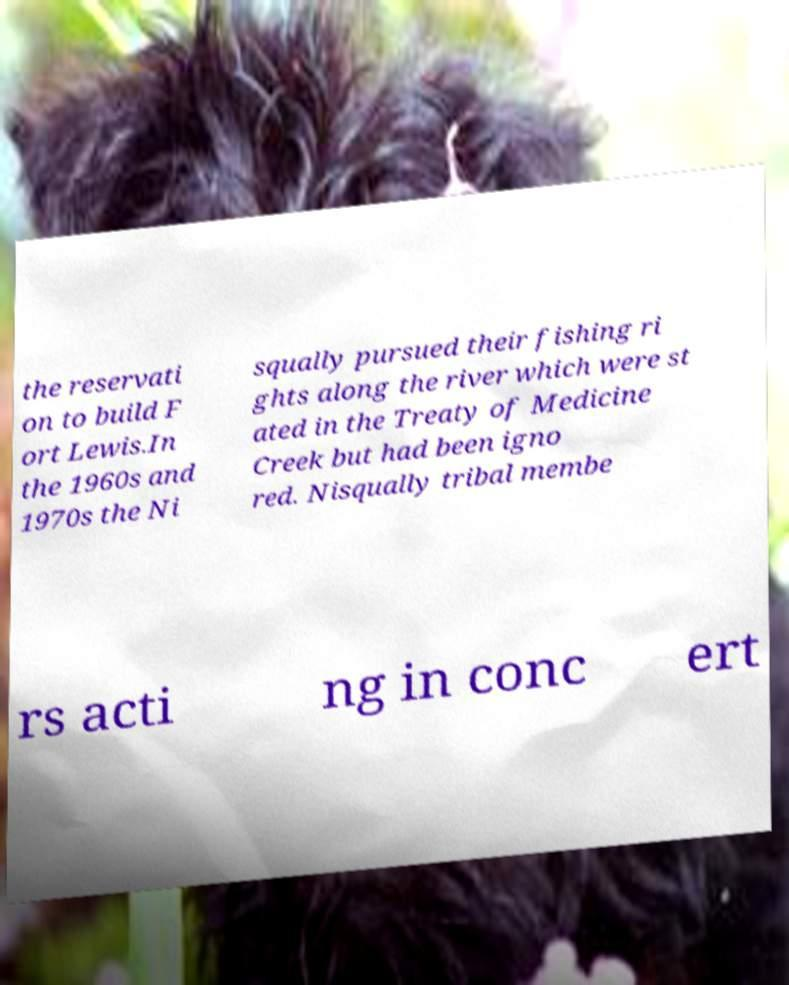Please identify and transcribe the text found in this image. the reservati on to build F ort Lewis.In the 1960s and 1970s the Ni squally pursued their fishing ri ghts along the river which were st ated in the Treaty of Medicine Creek but had been igno red. Nisqually tribal membe rs acti ng in conc ert 